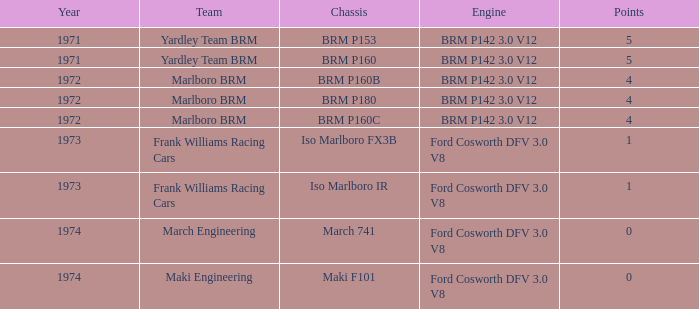What are the peak successes for marlboro brm team when utilizing the brm p180 chassis? 4.0. 